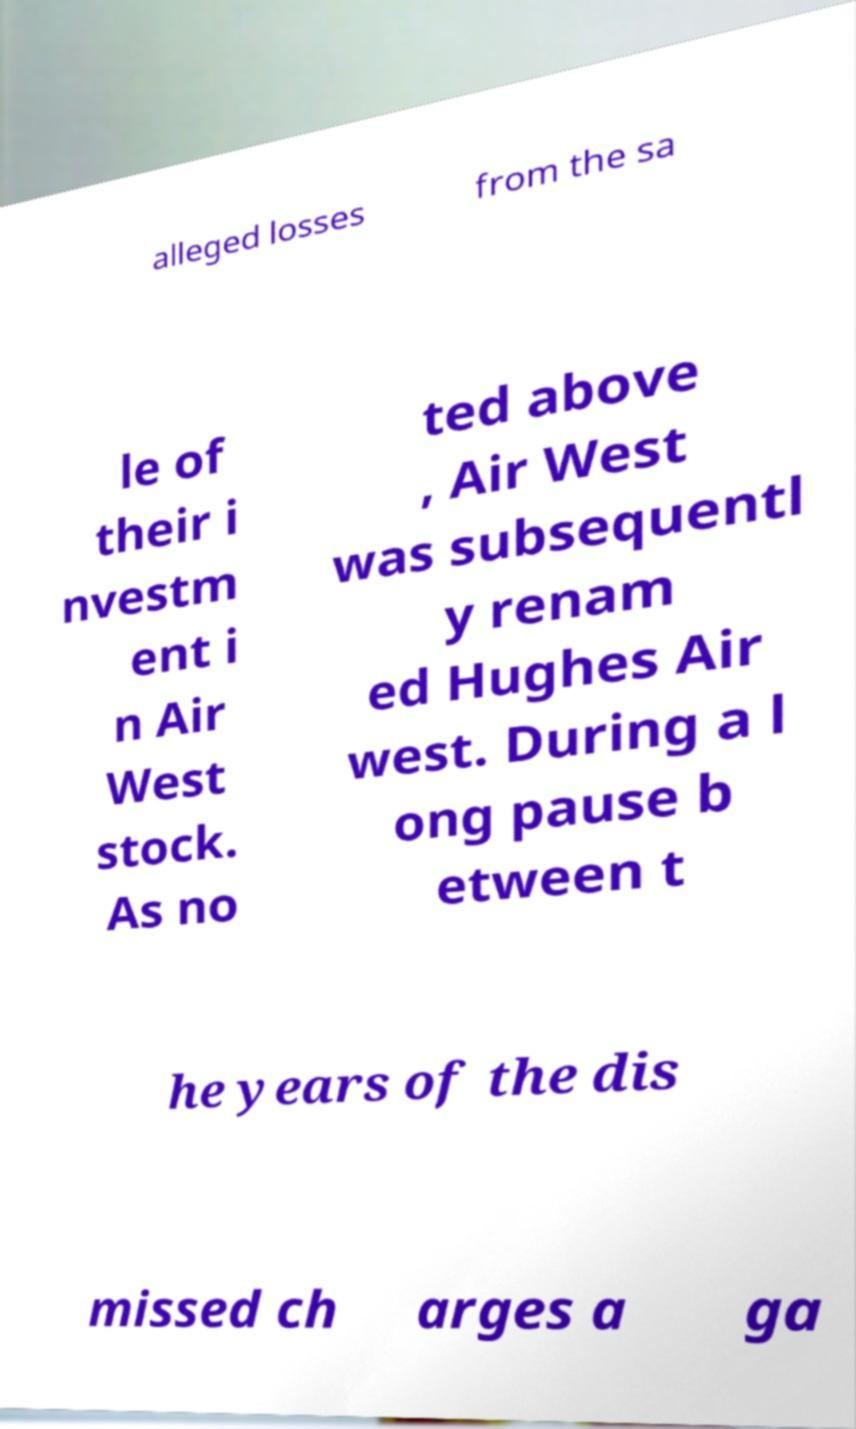Please identify and transcribe the text found in this image. alleged losses from the sa le of their i nvestm ent i n Air West stock. As no ted above , Air West was subsequentl y renam ed Hughes Air west. During a l ong pause b etween t he years of the dis missed ch arges a ga 